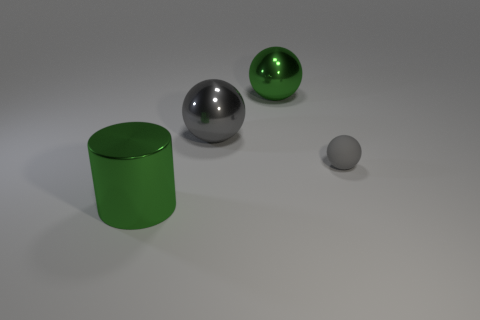Subtract all purple cylinders. How many gray spheres are left? 2 Add 1 big metallic spheres. How many objects exist? 5 Subtract all balls. How many objects are left? 1 Add 4 matte objects. How many matte objects are left? 5 Add 1 green spheres. How many green spheres exist? 2 Subtract 0 purple cubes. How many objects are left? 4 Subtract all yellow metallic cylinders. Subtract all big objects. How many objects are left? 1 